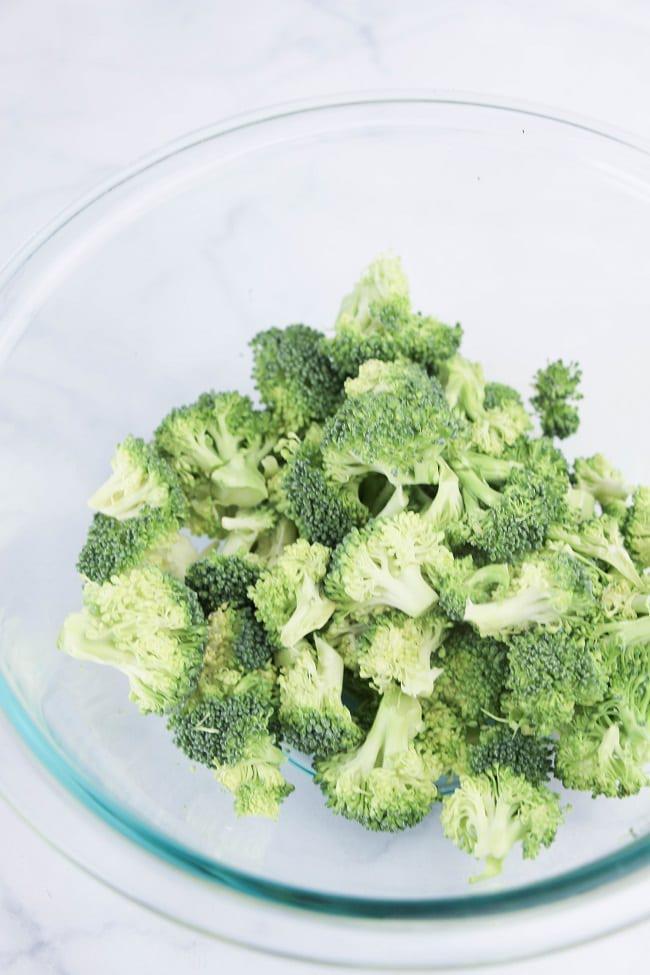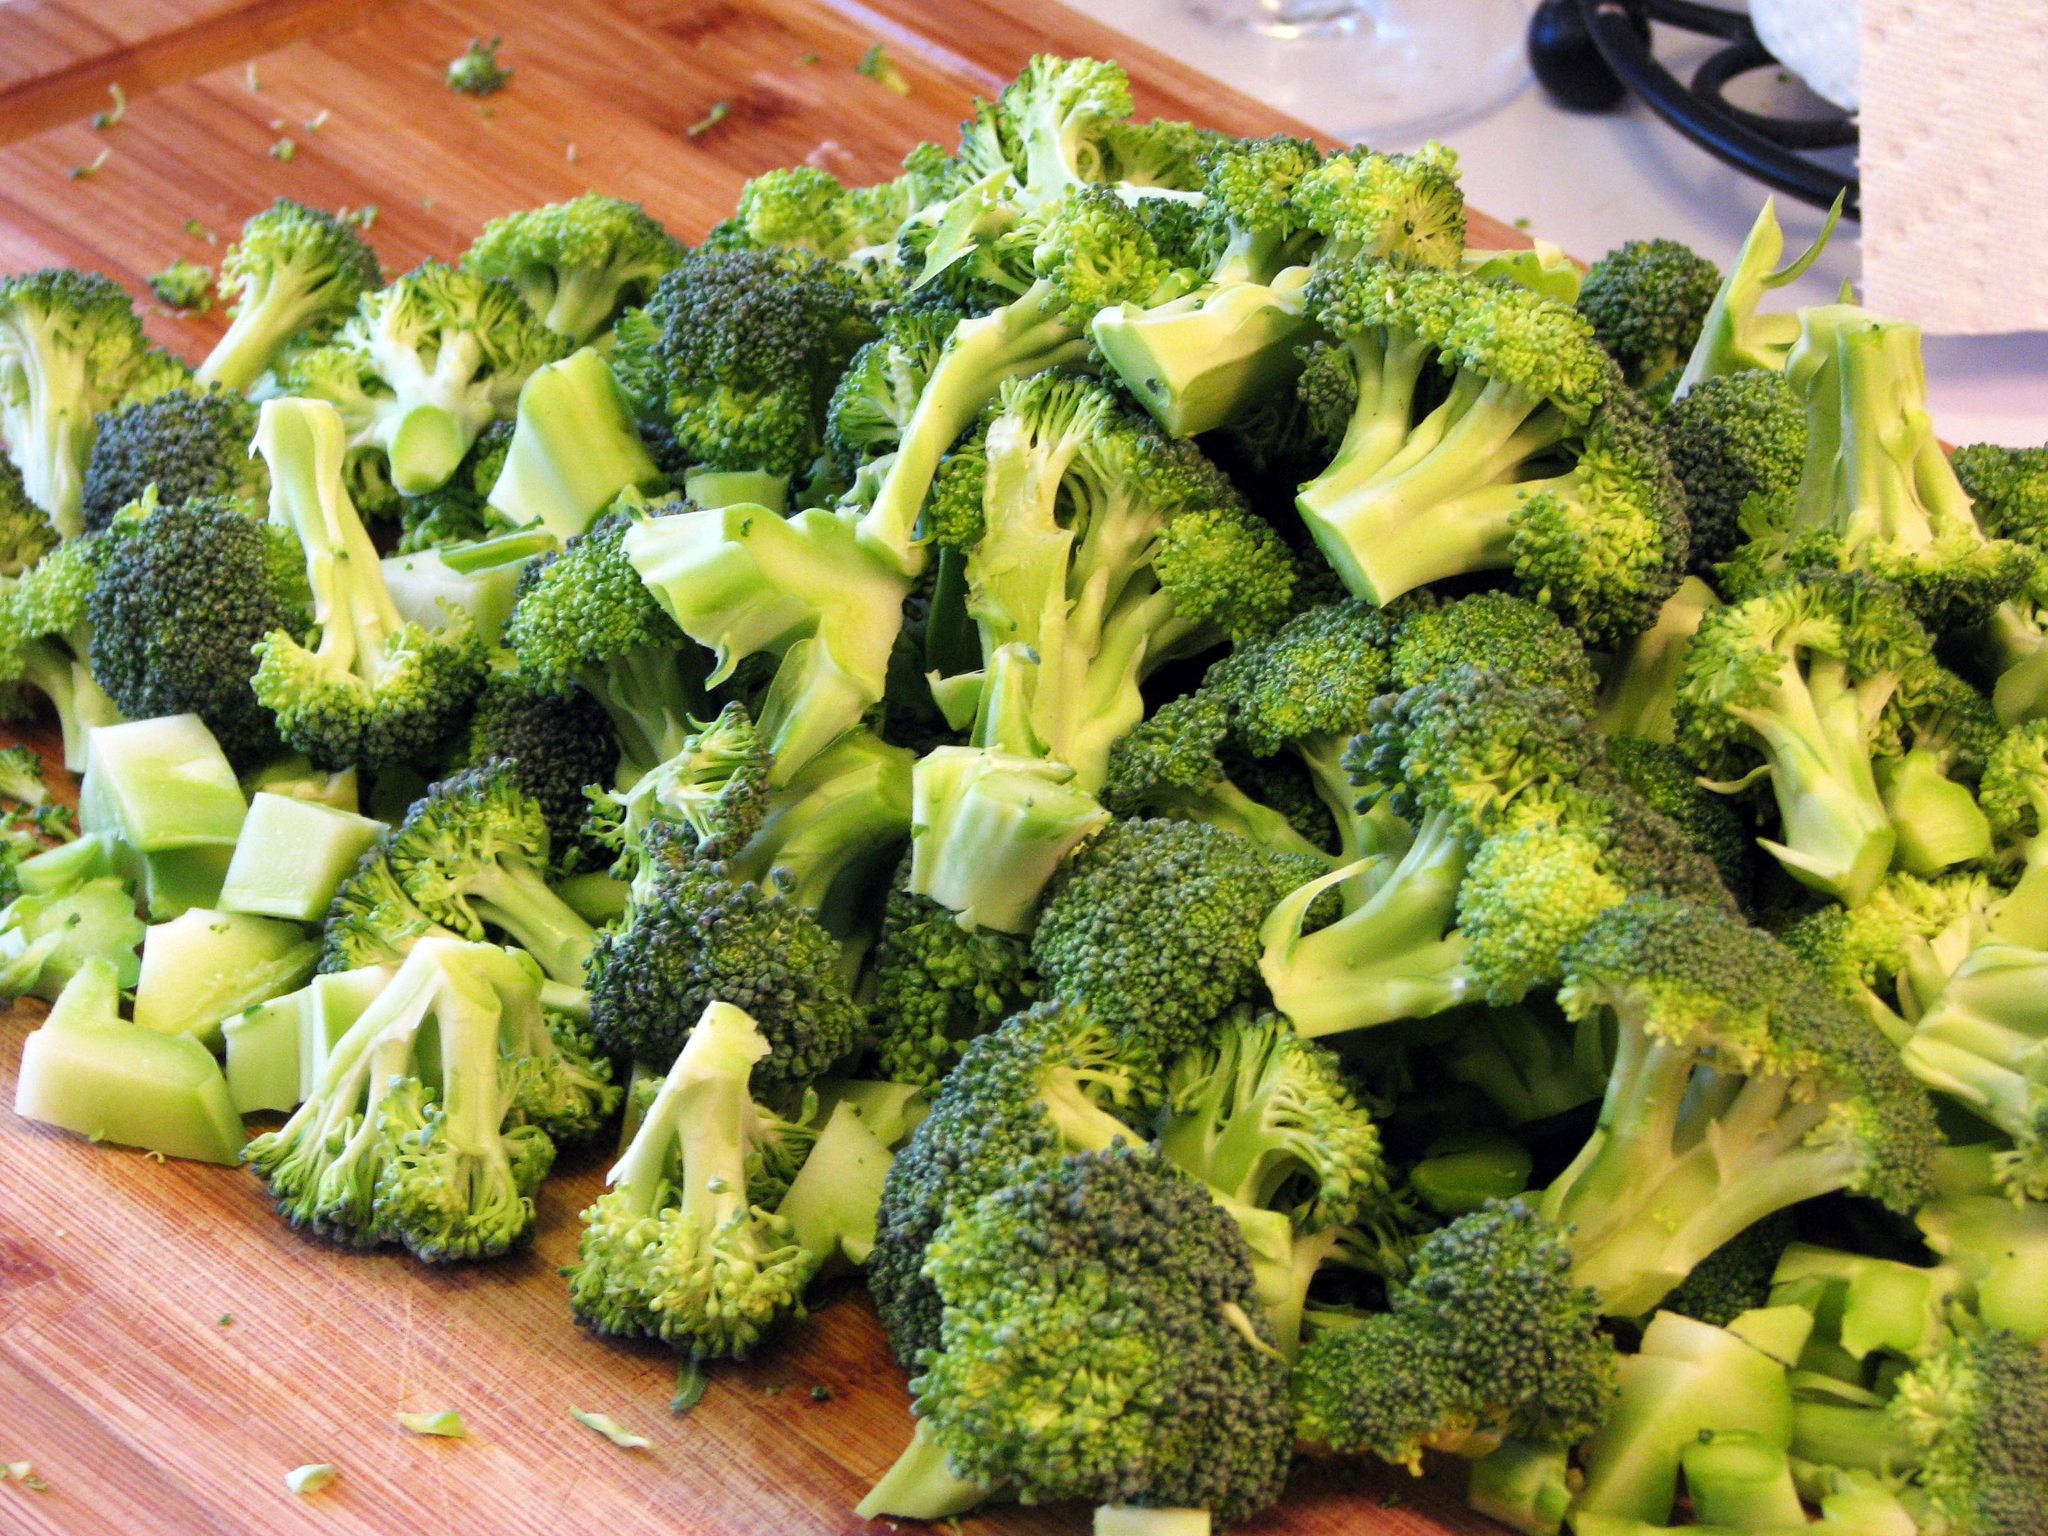The first image is the image on the left, the second image is the image on the right. Analyze the images presented: Is the assertion "One image shows broccoli on a wooden cutting board." valid? Answer yes or no. Yes. 